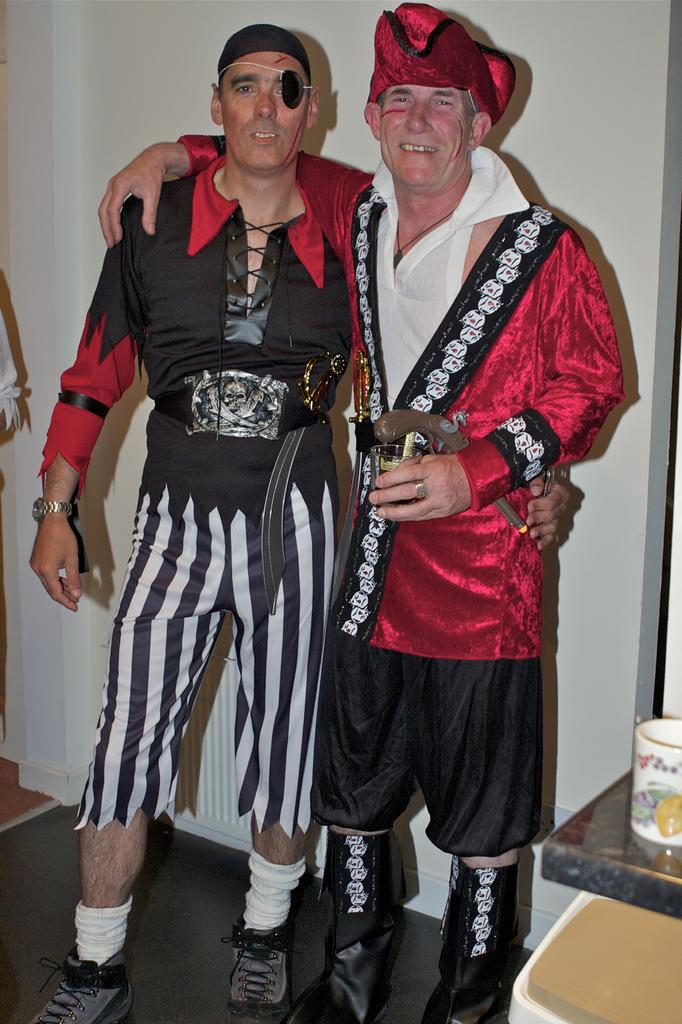How many people are in the image? There are two persons in the image. What are the persons wearing? The persons are wearing fancy dresses. What are the persons doing in the image? The persons are standing. What else can be seen in the image besides the persons? There are objects in the image. What is visible in the background of the image? There is a wall in the background of the image. How many arms does the toad have in the image? There is no toad present in the image, so it is not possible to determine the number of arms it might have. 